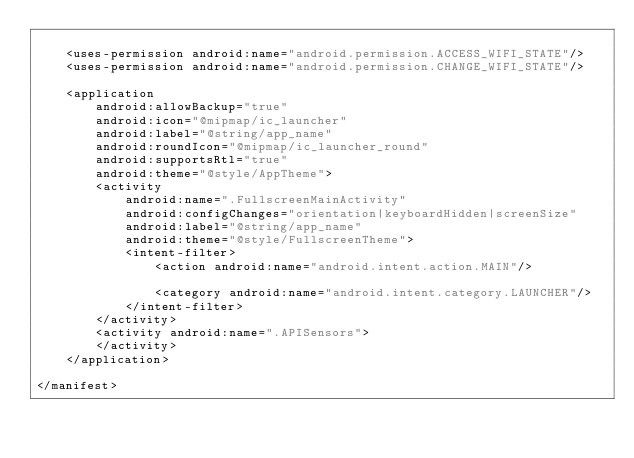Convert code to text. <code><loc_0><loc_0><loc_500><loc_500><_XML_>
    <uses-permission android:name="android.permission.ACCESS_WIFI_STATE"/>
    <uses-permission android:name="android.permission.CHANGE_WIFI_STATE"/>

    <application
        android:allowBackup="true"
        android:icon="@mipmap/ic_launcher"
        android:label="@string/app_name"
        android:roundIcon="@mipmap/ic_launcher_round"
        android:supportsRtl="true"
        android:theme="@style/AppTheme">
        <activity
            android:name=".FullscreenMainActivity"
            android:configChanges="orientation|keyboardHidden|screenSize"
            android:label="@string/app_name"
            android:theme="@style/FullscreenTheme">
            <intent-filter>
                <action android:name="android.intent.action.MAIN"/>

                <category android:name="android.intent.category.LAUNCHER"/>
            </intent-filter>
        </activity>
        <activity android:name=".APISensors">
        </activity>
    </application>

</manifest></code> 